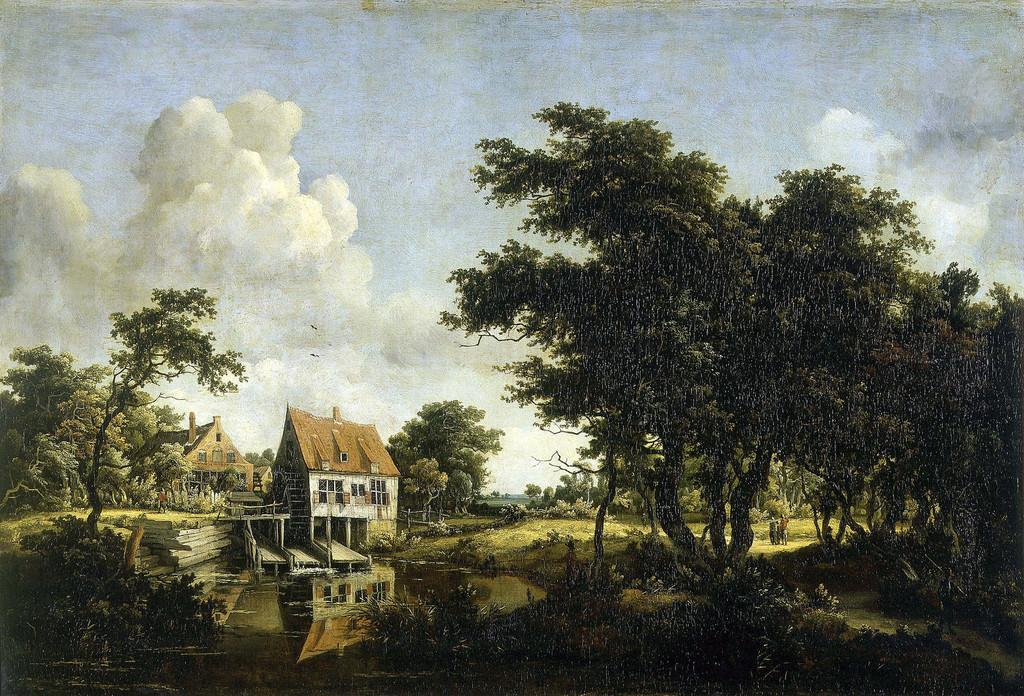What is the main subject of the image? The image contains a painting. What is depicted in the painting? The painting depicts trees, houses, and clouds in the sky. Is there any water visible in the painting? Yes, there is water visible at the bottom of the image. What type of horn can be seen in the painting? There is no horn present in the painting; it depicts trees, houses, clouds, and water. What color is the thread used to create the clouds in the painting? There is no thread used to create the clouds in the painting; it is a two-dimensional representation of clouds in the sky. 